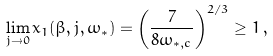Convert formula to latex. <formula><loc_0><loc_0><loc_500><loc_500>\lim _ { j \rightarrow 0 } x _ { 1 } ( \beta , j , \omega _ { \ast } ) = \left ( \frac { 7 } { 8 \omega _ { \ast , c } } \right ) ^ { 2 / 3 } \geq 1 \, ,</formula> 